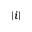Convert formula to latex. <formula><loc_0><loc_0><loc_500><loc_500>| i |</formula> 